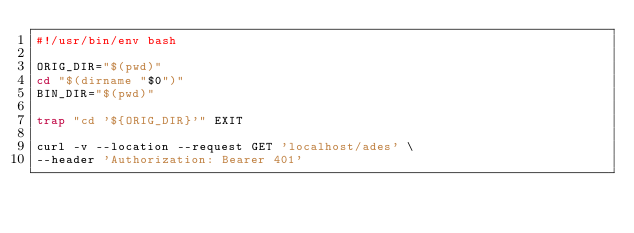<code> <loc_0><loc_0><loc_500><loc_500><_Bash_>#!/usr/bin/env bash

ORIG_DIR="$(pwd)"
cd "$(dirname "$0")"
BIN_DIR="$(pwd)"

trap "cd '${ORIG_DIR}'" EXIT

curl -v --location --request GET 'localhost/ades' \
--header 'Authorization: Bearer 401'
</code> 